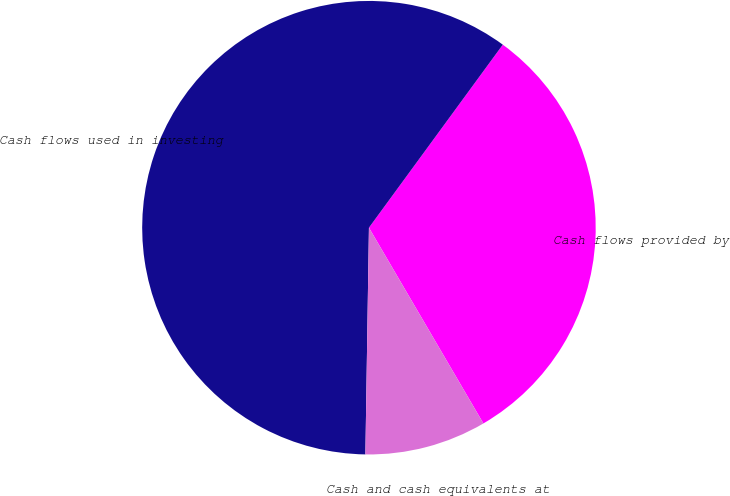Convert chart. <chart><loc_0><loc_0><loc_500><loc_500><pie_chart><fcel>Cash flows provided by<fcel>Cash flows used in investing<fcel>Cash and cash equivalents at<nl><fcel>31.53%<fcel>59.8%<fcel>8.67%<nl></chart> 